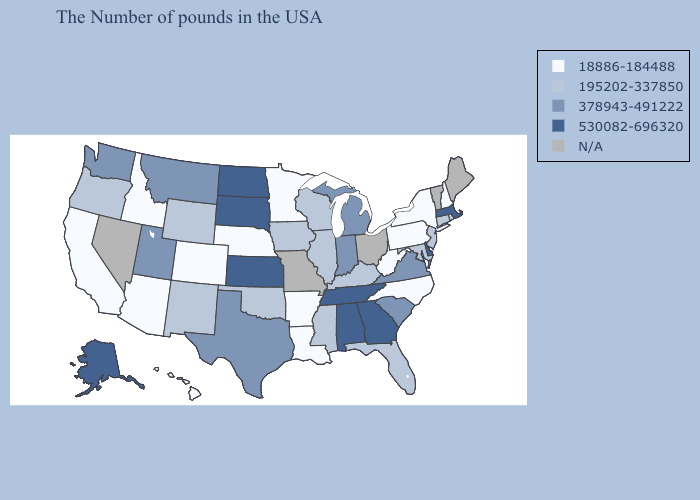Which states hav the highest value in the West?
Keep it brief. Alaska. Among the states that border Idaho , does Wyoming have the highest value?
Quick response, please. No. What is the value of Missouri?
Concise answer only. N/A. Which states have the highest value in the USA?
Write a very short answer. Massachusetts, Delaware, Georgia, Alabama, Tennessee, Kansas, South Dakota, North Dakota, Alaska. Among the states that border Wisconsin , does Minnesota have the highest value?
Answer briefly. No. Is the legend a continuous bar?
Write a very short answer. No. Name the states that have a value in the range 530082-696320?
Give a very brief answer. Massachusetts, Delaware, Georgia, Alabama, Tennessee, Kansas, South Dakota, North Dakota, Alaska. Which states hav the highest value in the South?
Short answer required. Delaware, Georgia, Alabama, Tennessee. Name the states that have a value in the range N/A?
Give a very brief answer. Maine, Vermont, Ohio, Missouri, Nevada. What is the highest value in the Northeast ?
Concise answer only. 530082-696320. What is the value of Virginia?
Write a very short answer. 378943-491222. What is the highest value in states that border Illinois?
Be succinct. 378943-491222. Name the states that have a value in the range 195202-337850?
Give a very brief answer. Rhode Island, Connecticut, New Jersey, Maryland, Florida, Kentucky, Wisconsin, Illinois, Mississippi, Iowa, Oklahoma, Wyoming, New Mexico, Oregon. What is the value of Maine?
Write a very short answer. N/A. 